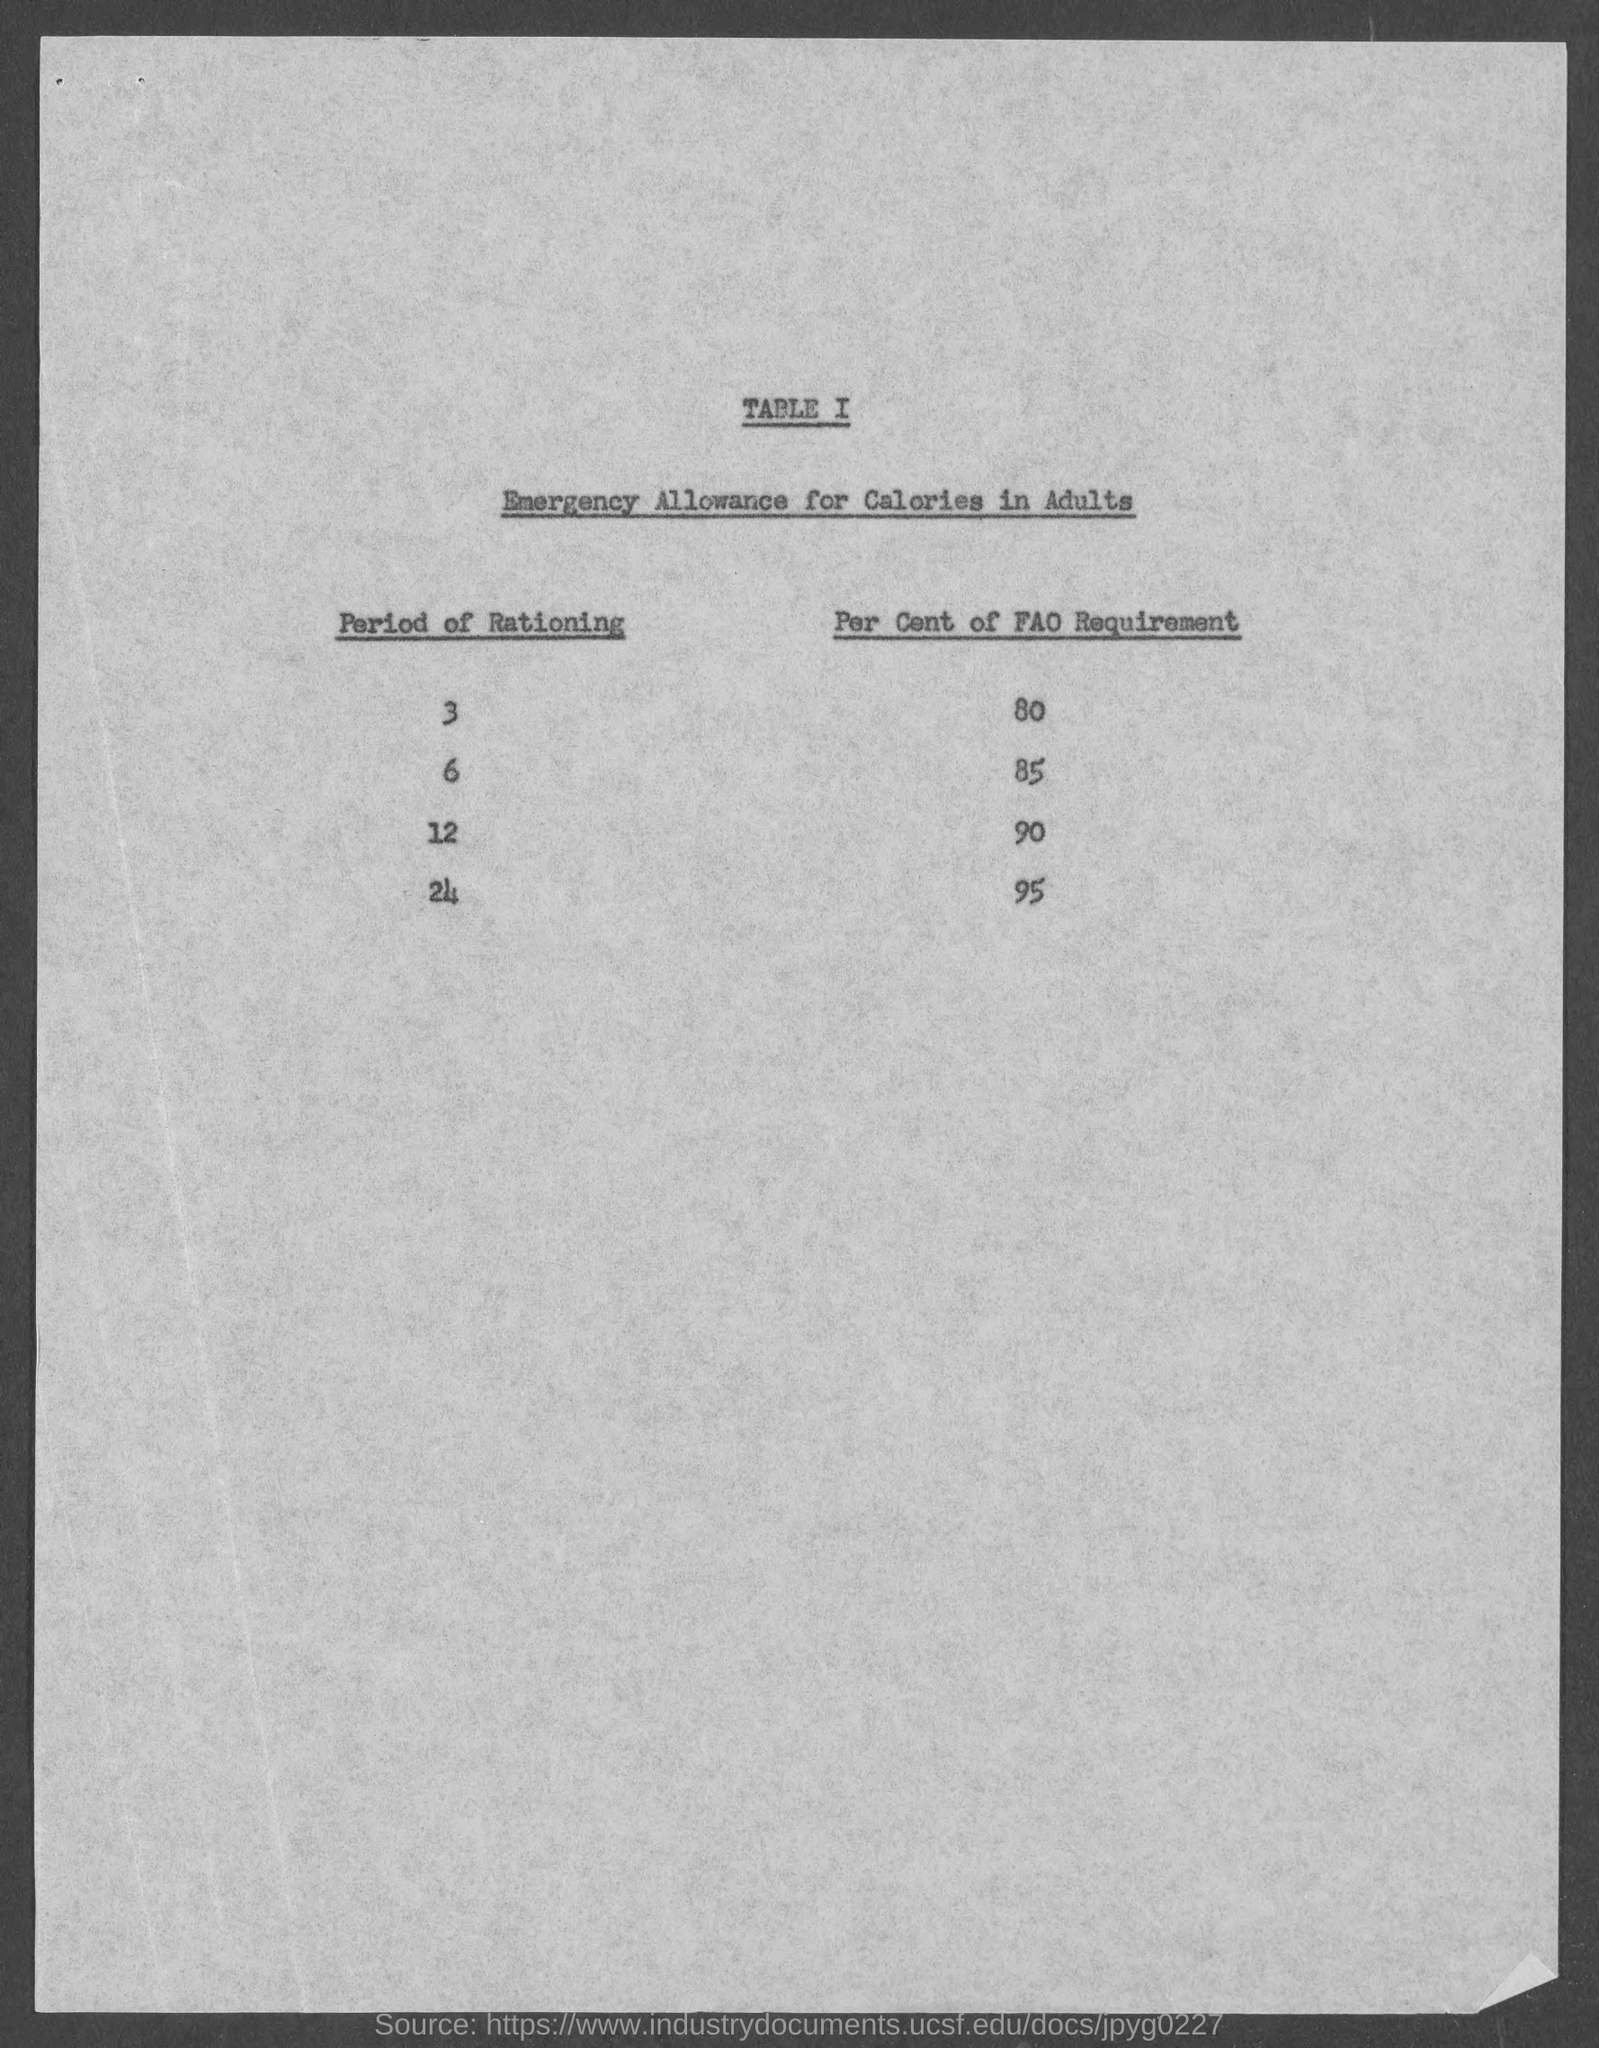Highlight a few significant elements in this photo. The title of TABLE I is "Emergency Allowance for Calories in Adults". 